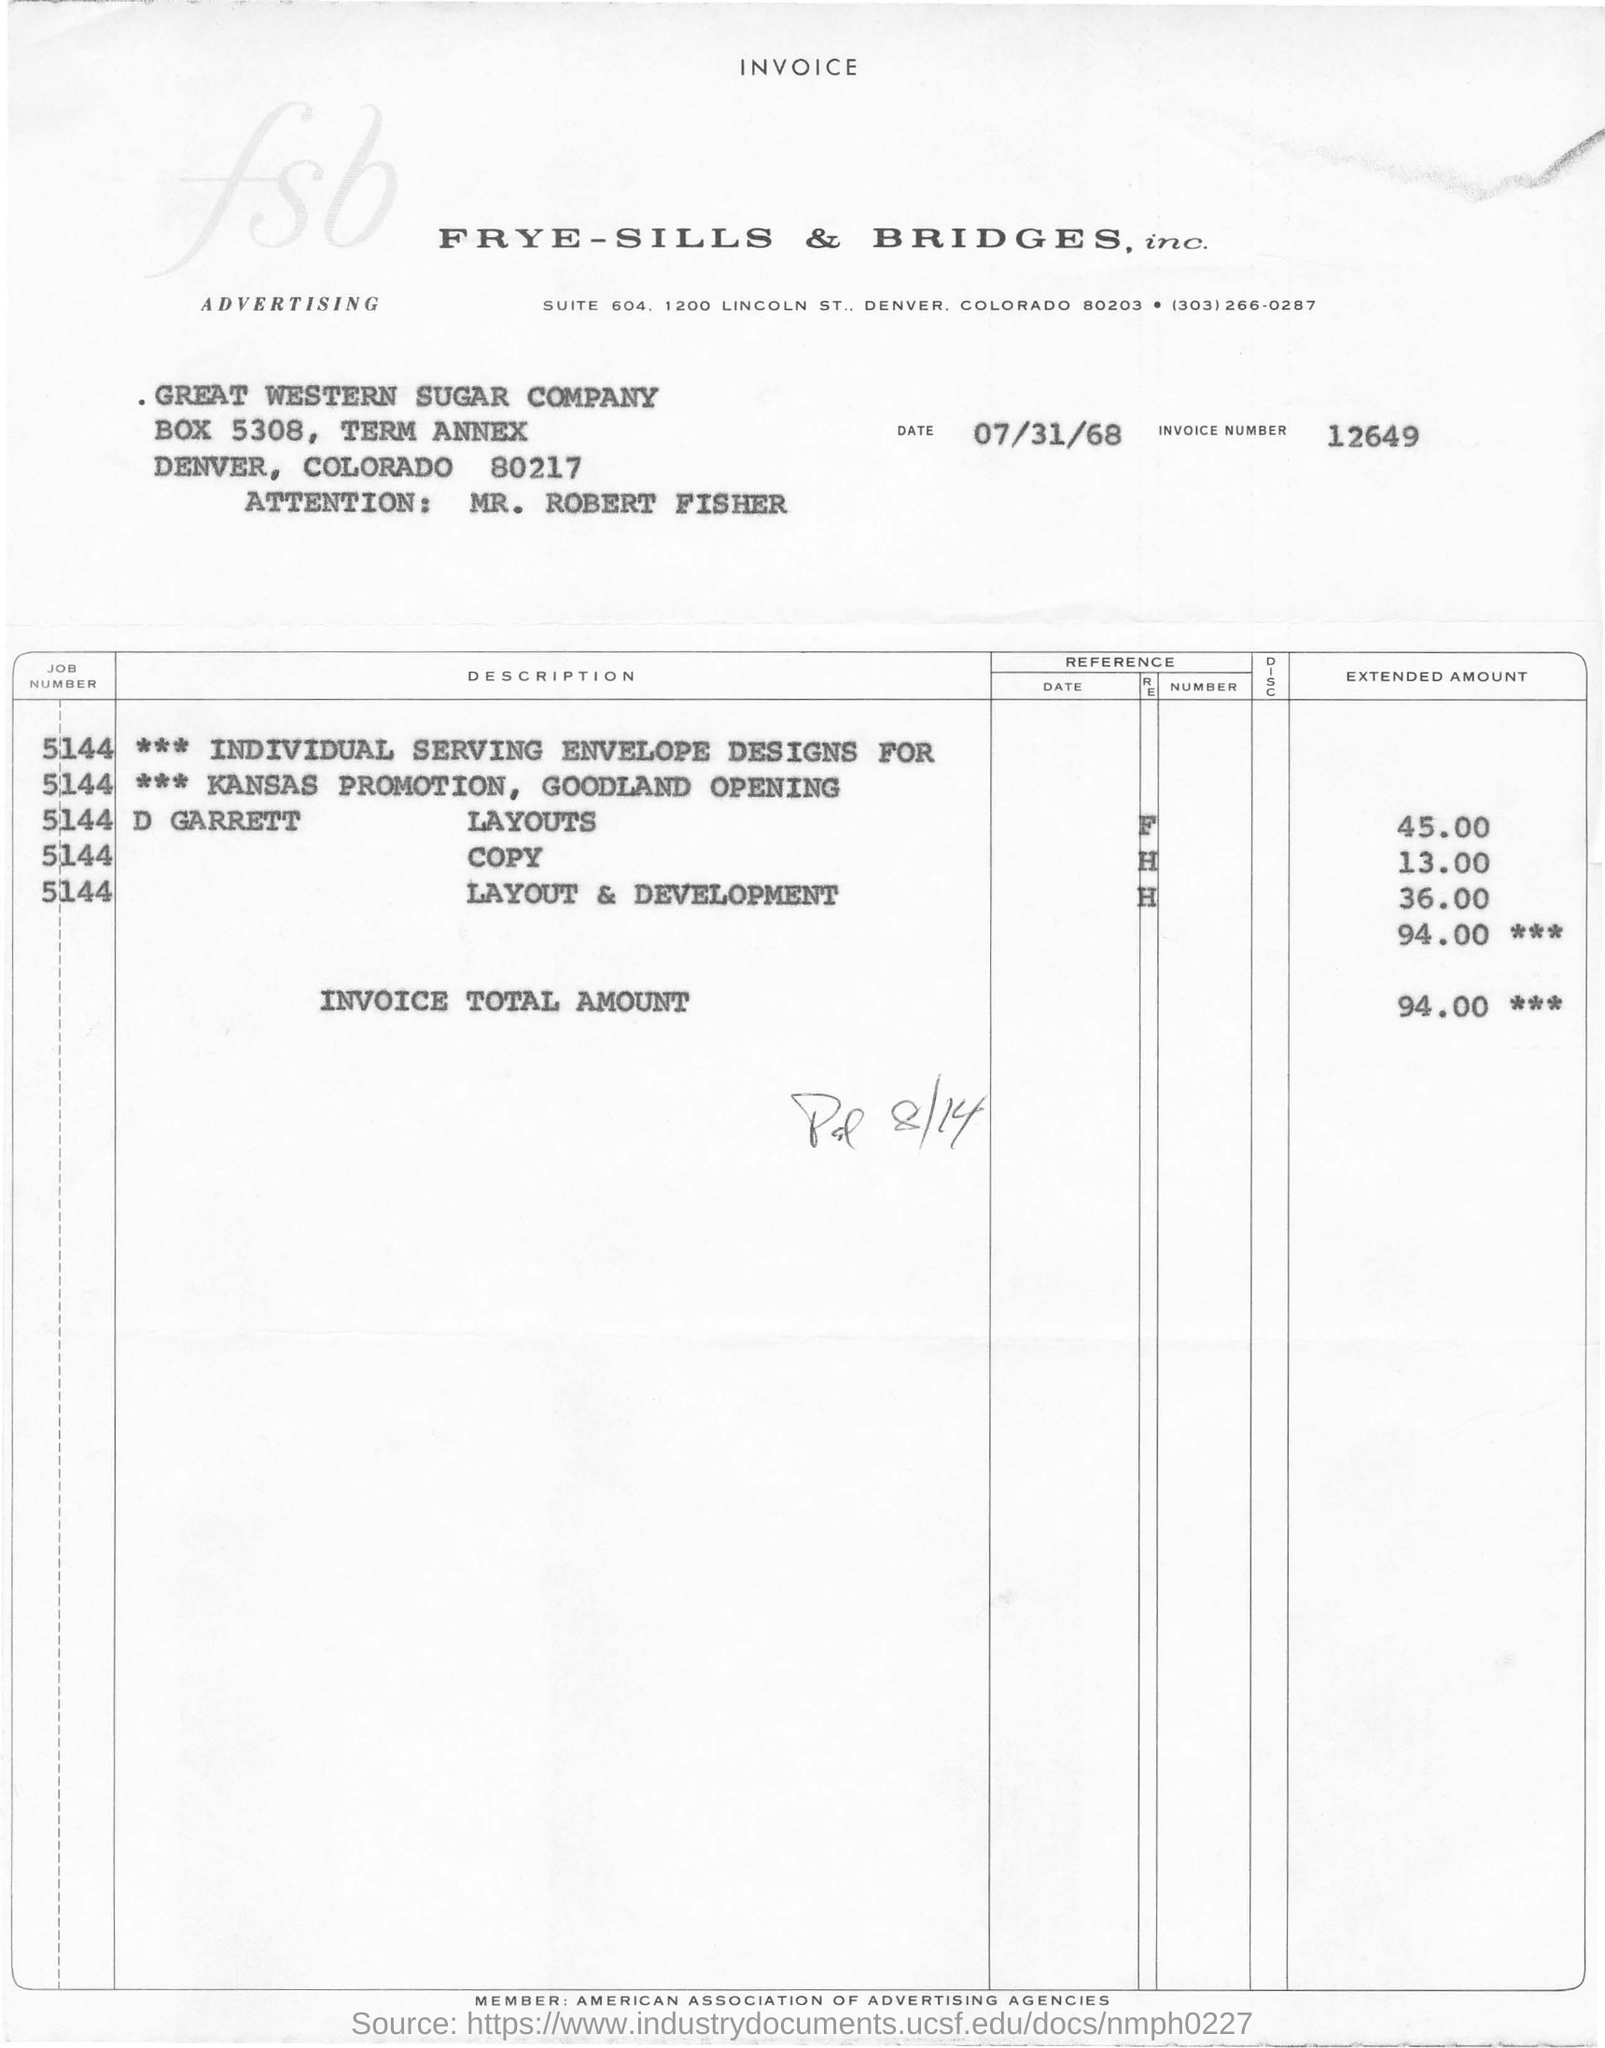Which company is raising this invoice?
Give a very brief answer. FRYE-SILLS & BRIDGES, inc. What is the invoice number
Keep it short and to the point. 12649. What is the invoice number given?
Keep it short and to the point. 12649. Invoice total amount is
Offer a terse response. 94. 